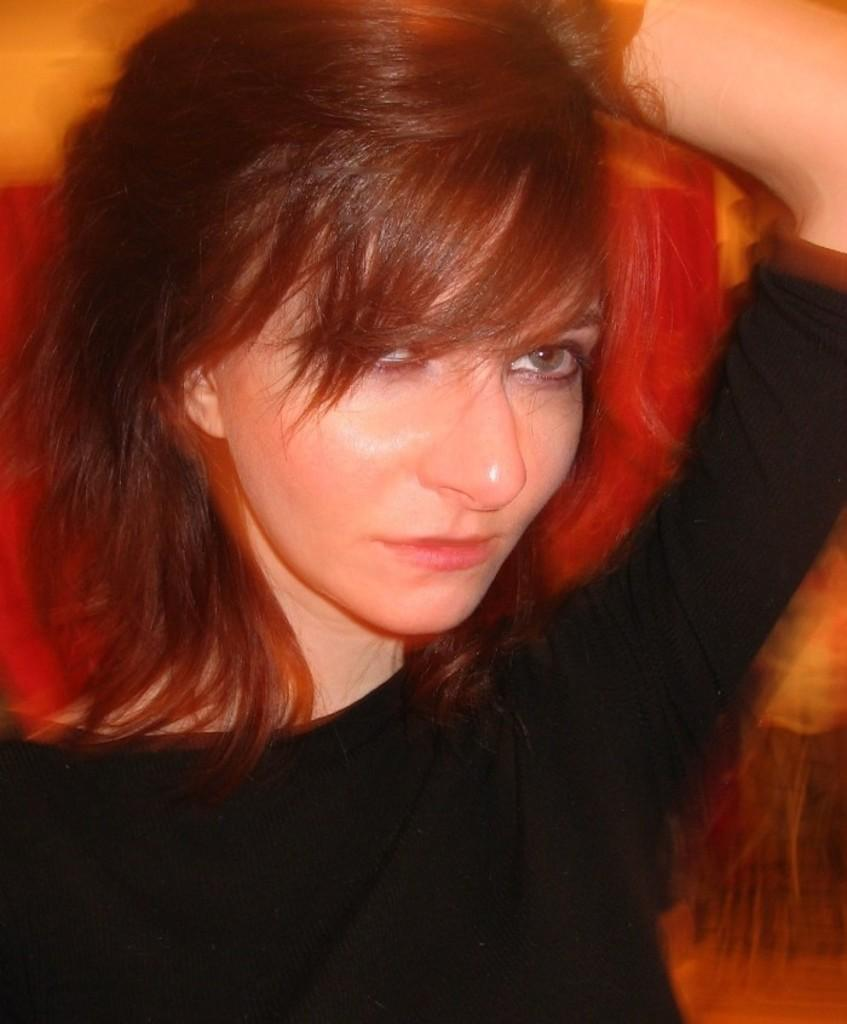Who is the main subject in the image? There is a lady in the image. What is the lady wearing? The lady is wearing a black dress. Can you see any fairies flying around the lady in the image? No, there are no fairies present in the image. 